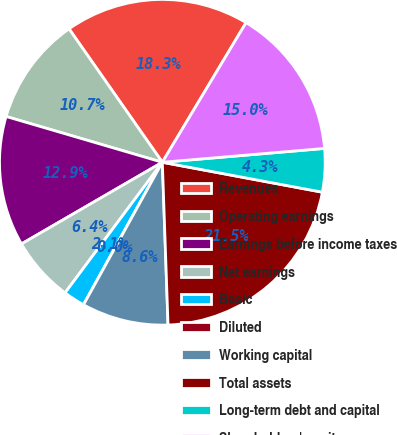Convert chart to OTSL. <chart><loc_0><loc_0><loc_500><loc_500><pie_chart><fcel>Revenues<fcel>Operating earnings<fcel>Earnings before income taxes<fcel>Net earnings<fcel>Basic<fcel>Diluted<fcel>Working capital<fcel>Total assets<fcel>Long-term debt and capital<fcel>Shareholders' equity<nl><fcel>18.31%<fcel>10.75%<fcel>12.9%<fcel>6.45%<fcel>2.15%<fcel>0.0%<fcel>8.6%<fcel>21.5%<fcel>4.3%<fcel>15.05%<nl></chart> 